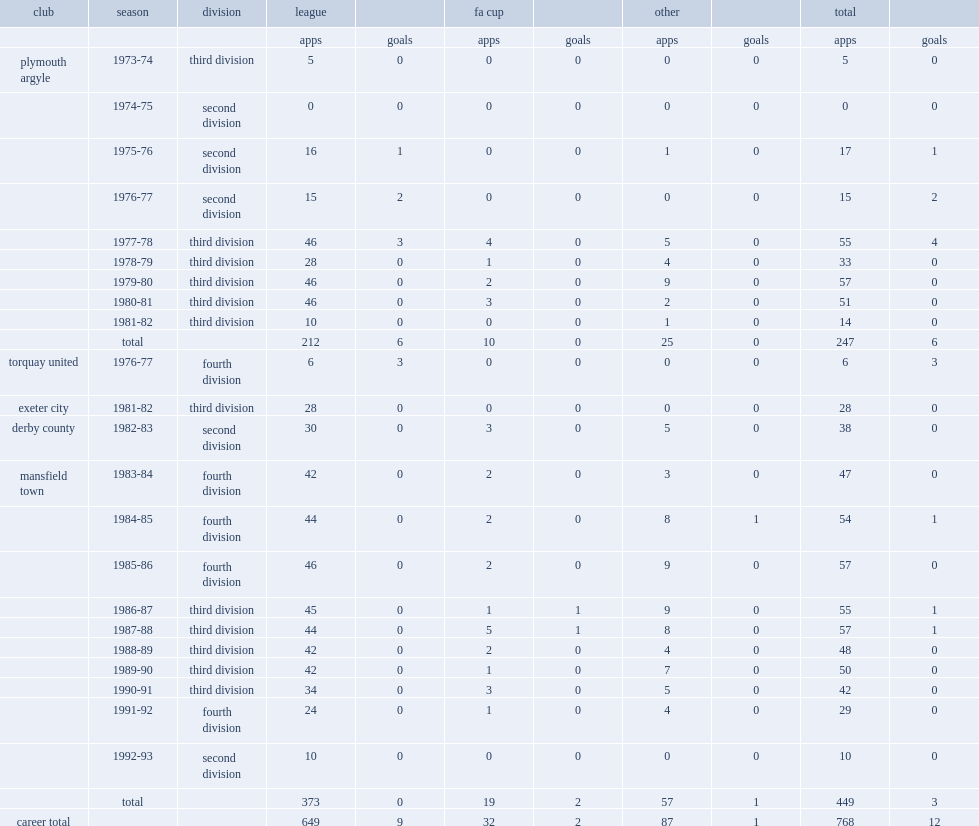How many league appearances did george foster have in a 20-year career in the football league? 649.0. 